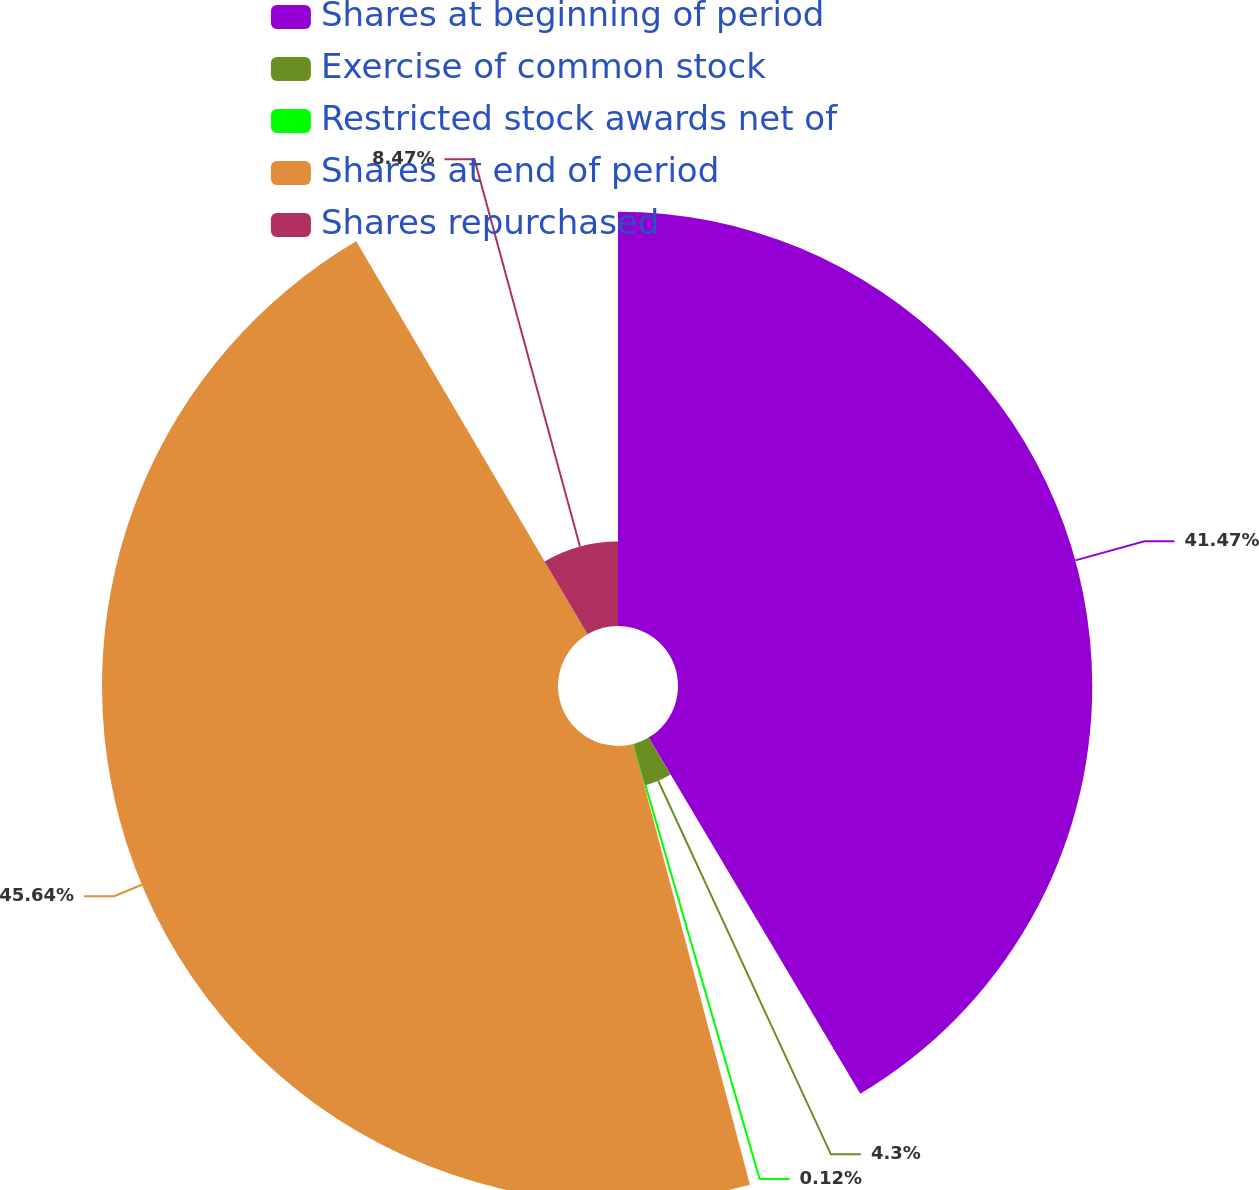Convert chart. <chart><loc_0><loc_0><loc_500><loc_500><pie_chart><fcel>Shares at beginning of period<fcel>Exercise of common stock<fcel>Restricted stock awards net of<fcel>Shares at end of period<fcel>Shares repurchased<nl><fcel>41.47%<fcel>4.3%<fcel>0.12%<fcel>45.65%<fcel>8.47%<nl></chart> 